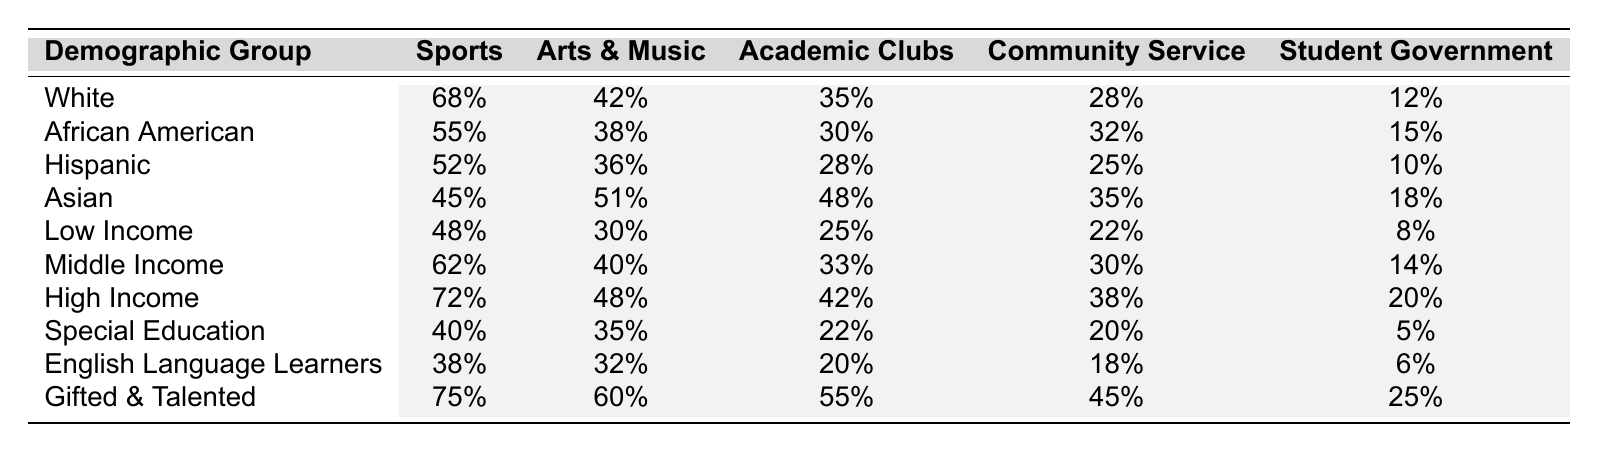What is the participation rate for Hispanic students in sports? The table shows the participation rate for Hispanic students in sports, which is listed under the "Sports" column for that demographic group. The percentage is 52%.
Answer: 52% Which demographic group has the highest participation in Arts & Music? By examining the "Arts & Music" column, the highest percentage is 60%, associated with the Gifted & Talented group.
Answer: Gifted & Talented Calculate the average participation rate in Community Service across all demographic groups. First, add the participation rates: 28 + 32 + 25 + 35 + 22 + 30 + 38 + 20 + 18 + 45 =  278. Then, divide by the number of groups (10) to find the average: 278/10 = 27.8%.
Answer: 27.8% Do more Asian students participate in Academic Clubs than Low Income students? Check the "Academic Clubs" column: Asian students have a participation rate of 48%, while Low Income students have 25%. Since 48% is greater than 25%, the statement is true.
Answer: Yes What is the difference in participation rates for Student Government between High Income and Special Education groups? Look at the "Student Government" column: High Income has 20% while Special Education has 5%. The difference is calculated as 20 - 5 = 15%.
Answer: 15% Which demographic group has the lowest participation rate in Sports? Reviewing the "Sports" column, the demographic group with the lowest participation rate is Special Education, which has 40%.
Answer: Special Education Is the participation in Community Service for Low Income students higher than that of Hispanic students? In the "Community Service" column, Low Income students show 22% participation and Hispanic students show 25%. Since 22% is less than 25%, the answer is no.
Answer: No What demographic groups have participation rates greater than 50% in Academic Clubs? Looking at the "Academic Clubs" column, African American (30%) and Hispanic (28%) do not meet the criteria. The only groups above 50% are Asian (48%) and Gifted & Talented (55%), hence the answer is Gifted & Talented.
Answer: Gifted & Talented What is the sum of participation rates in Arts & Music for all income groups? The income groups are Low Income (30%), Middle Income (40%), and High Income (48%). Adding these gives 30 + 40 + 48 = 118%.
Answer: 118% Which demographic group participates the least in all activities combined? We calculate the total for each demographic group's participation across all activities. The lowest sum belongs to Special Education: 40 + 35 + 22 + 20 + 5 = 122%.
Answer: Special Education 